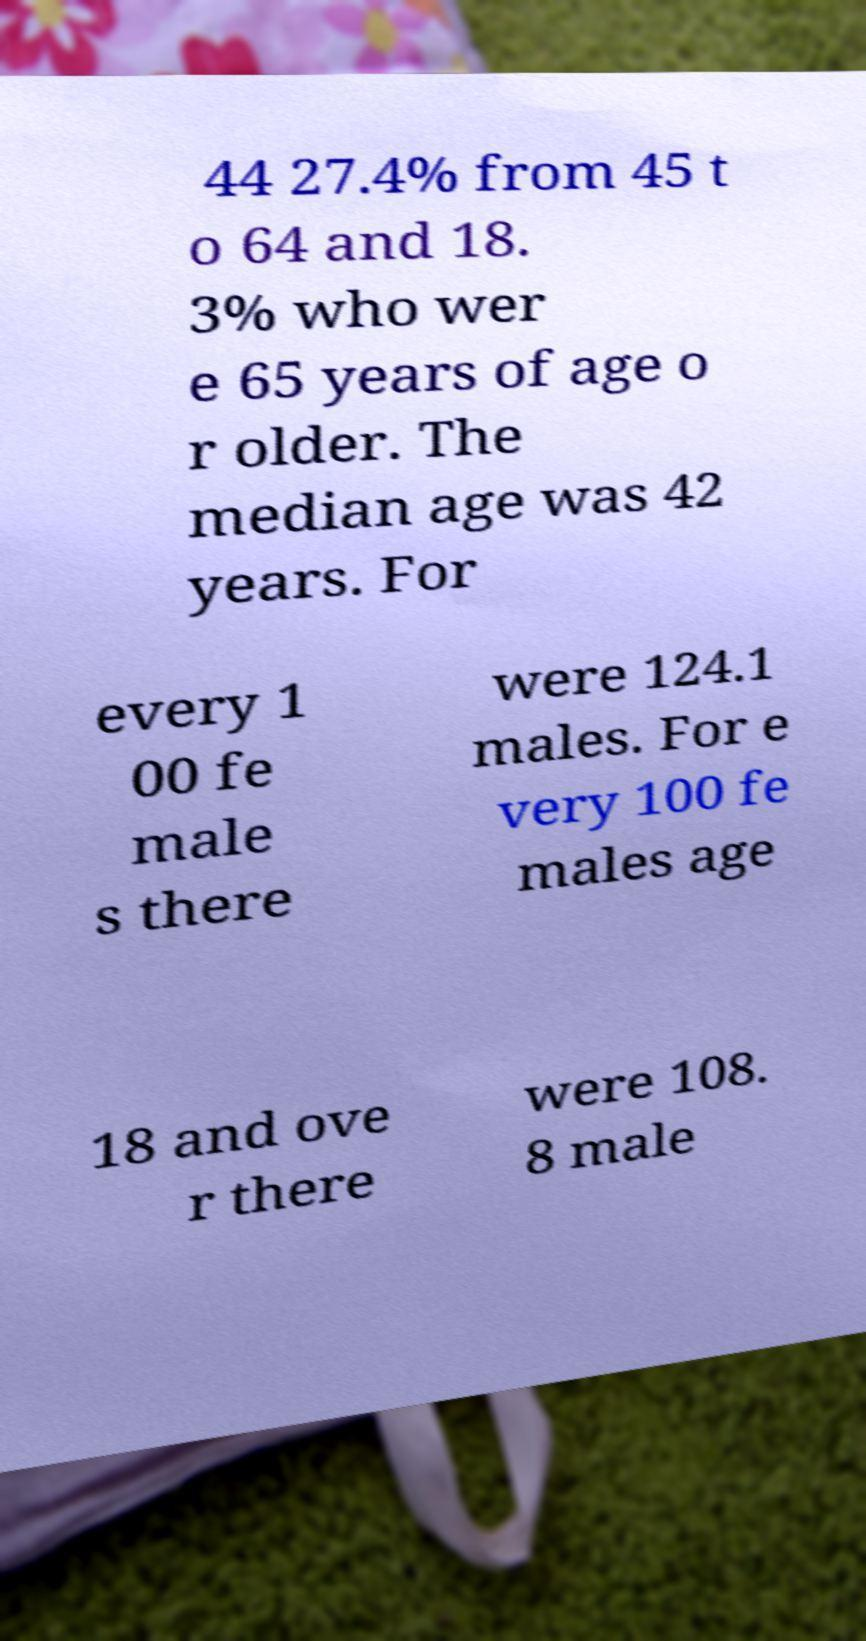What messages or text are displayed in this image? I need them in a readable, typed format. 44 27.4% from 45 t o 64 and 18. 3% who wer e 65 years of age o r older. The median age was 42 years. For every 1 00 fe male s there were 124.1 males. For e very 100 fe males age 18 and ove r there were 108. 8 male 